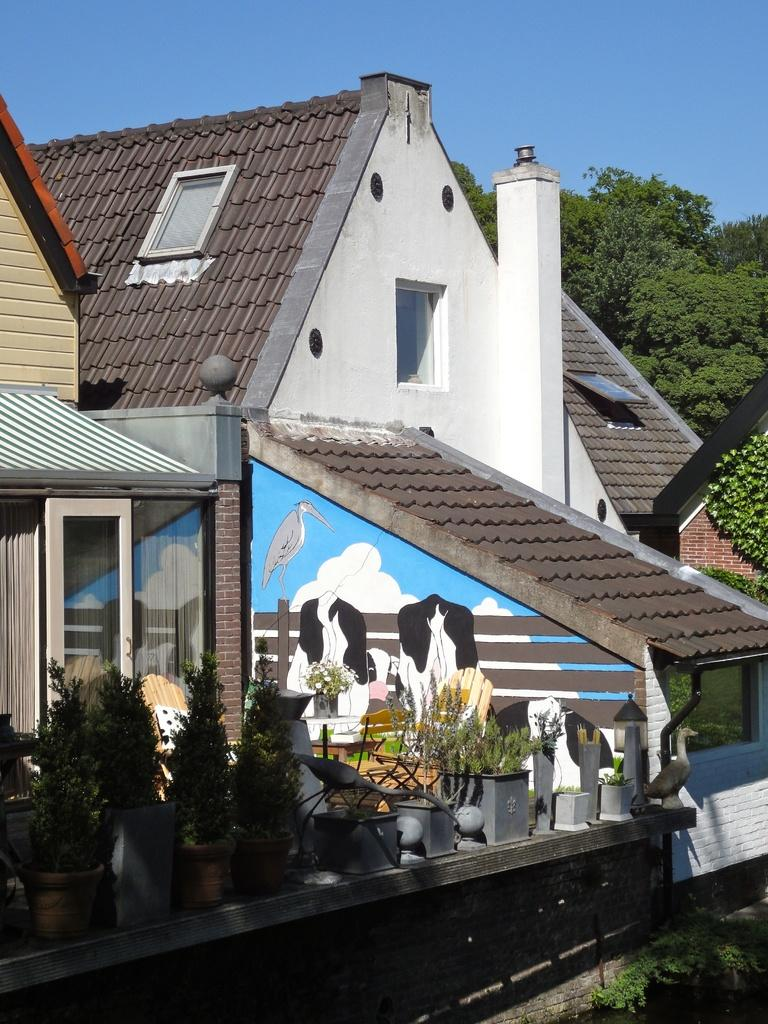What type of structures can be seen in the image? There are buildings in the image. What natural elements are present in the image? There are trees in the image. Are there any objects related to plants in the image? Yes, there are plant pots in the image. What type of artwork is visible in the image? There are paintings on the wall in the image. Can you describe any other objects in the image? There are other objects in the image, but their specific details are not mentioned in the provided facts. What is visible in the background of the image? The sky is visible in the background of the image. How many ducks are flying in the sky in the image? There are no ducks present in the image; the sky is visible in the background, but no ducks are mentioned in the provided facts. 